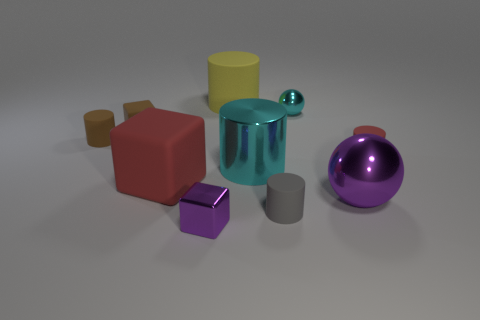Subtract all tiny blocks. How many blocks are left? 1 Subtract all cubes. How many objects are left? 7 Subtract 3 cubes. How many cubes are left? 0 Subtract 0 blue cylinders. How many objects are left? 10 Subtract all cyan balls. Subtract all yellow cylinders. How many balls are left? 1 Subtract all green spheres. How many green blocks are left? 0 Subtract all red cubes. Subtract all large gray rubber cylinders. How many objects are left? 9 Add 7 small brown objects. How many small brown objects are left? 9 Add 1 gray rubber objects. How many gray rubber objects exist? 2 Subtract all gray cylinders. How many cylinders are left? 4 